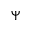Convert formula to latex. <formula><loc_0><loc_0><loc_500><loc_500>\Psi</formula> 